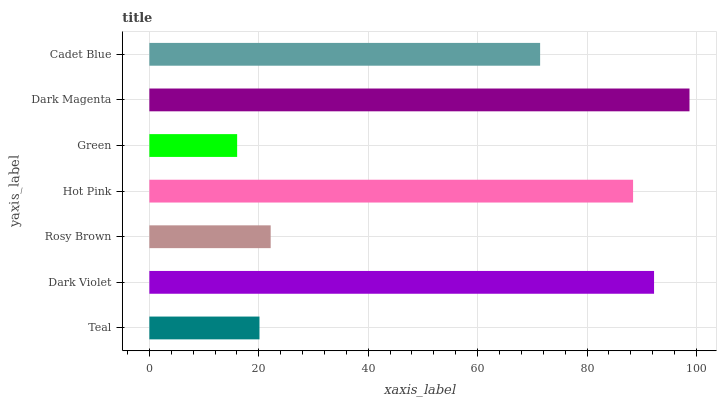Is Green the minimum?
Answer yes or no. Yes. Is Dark Magenta the maximum?
Answer yes or no. Yes. Is Dark Violet the minimum?
Answer yes or no. No. Is Dark Violet the maximum?
Answer yes or no. No. Is Dark Violet greater than Teal?
Answer yes or no. Yes. Is Teal less than Dark Violet?
Answer yes or no. Yes. Is Teal greater than Dark Violet?
Answer yes or no. No. Is Dark Violet less than Teal?
Answer yes or no. No. Is Cadet Blue the high median?
Answer yes or no. Yes. Is Cadet Blue the low median?
Answer yes or no. Yes. Is Dark Violet the high median?
Answer yes or no. No. Is Hot Pink the low median?
Answer yes or no. No. 